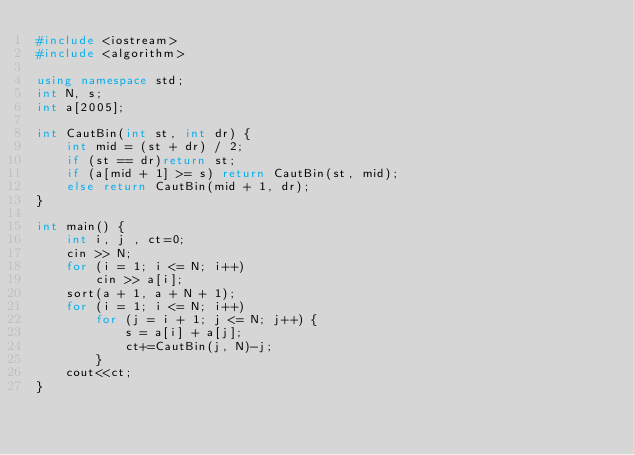<code> <loc_0><loc_0><loc_500><loc_500><_C++_>#include <iostream>
#include <algorithm>

using namespace std;
int N, s;
int a[2005];

int CautBin(int st, int dr) {
    int mid = (st + dr) / 2;
    if (st == dr)return st;
    if (a[mid + 1] >= s) return CautBin(st, mid);
    else return CautBin(mid + 1, dr);
}

int main() {
    int i, j , ct=0;
    cin >> N;
    for (i = 1; i <= N; i++)
        cin >> a[i];
    sort(a + 1, a + N + 1);
    for (i = 1; i <= N; i++)
        for (j = i + 1; j <= N; j++) {
            s = a[i] + a[j];
            ct+=CautBin(j, N)-j;
        }
    cout<<ct;
}</code> 